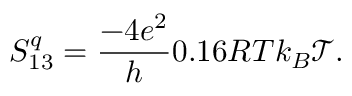Convert formula to latex. <formula><loc_0><loc_0><loc_500><loc_500>S _ { 1 3 } ^ { q } = \frac { - 4 e ^ { 2 } } { h } 0 . 1 6 R T k _ { B } \mathcal { T } .</formula> 